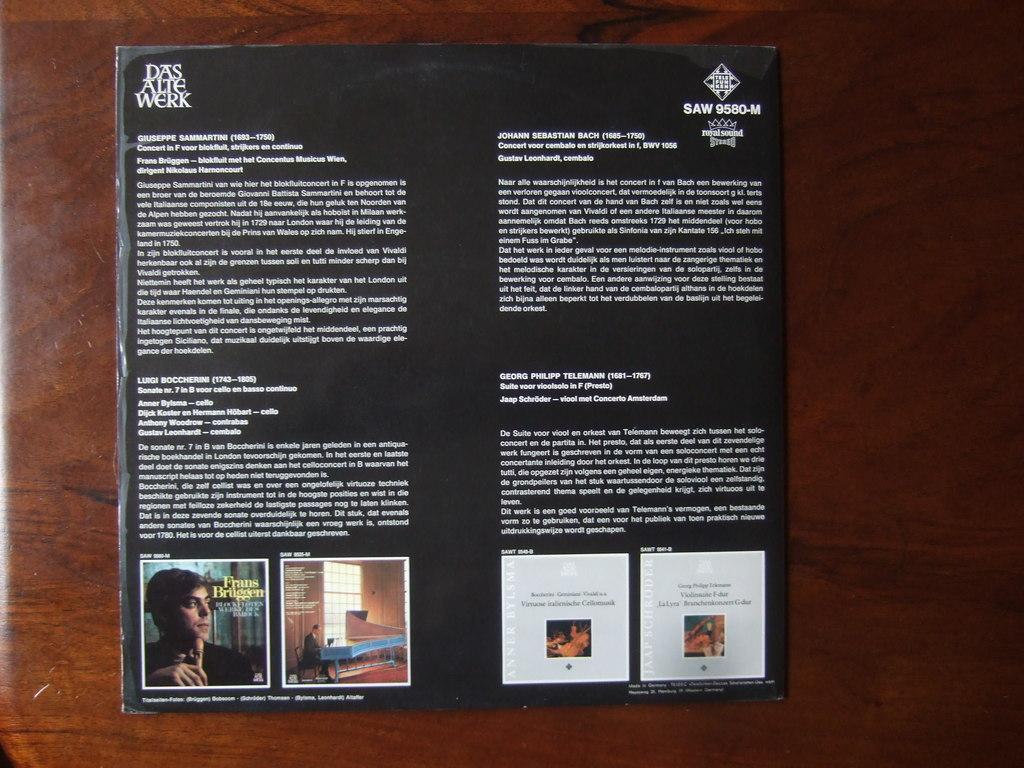Could you give a brief overview of what you see in this image? In this image I can see the brown colored surface and on the brown colored surface I can see a black colored paper on which I can see few words written and few images of a person. 